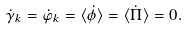Convert formula to latex. <formula><loc_0><loc_0><loc_500><loc_500>\dot { \gamma } _ { k } = \dot { \varphi } _ { k } = \langle \dot { \phi } \rangle = \langle \dot { \Pi } \rangle = 0 .</formula> 